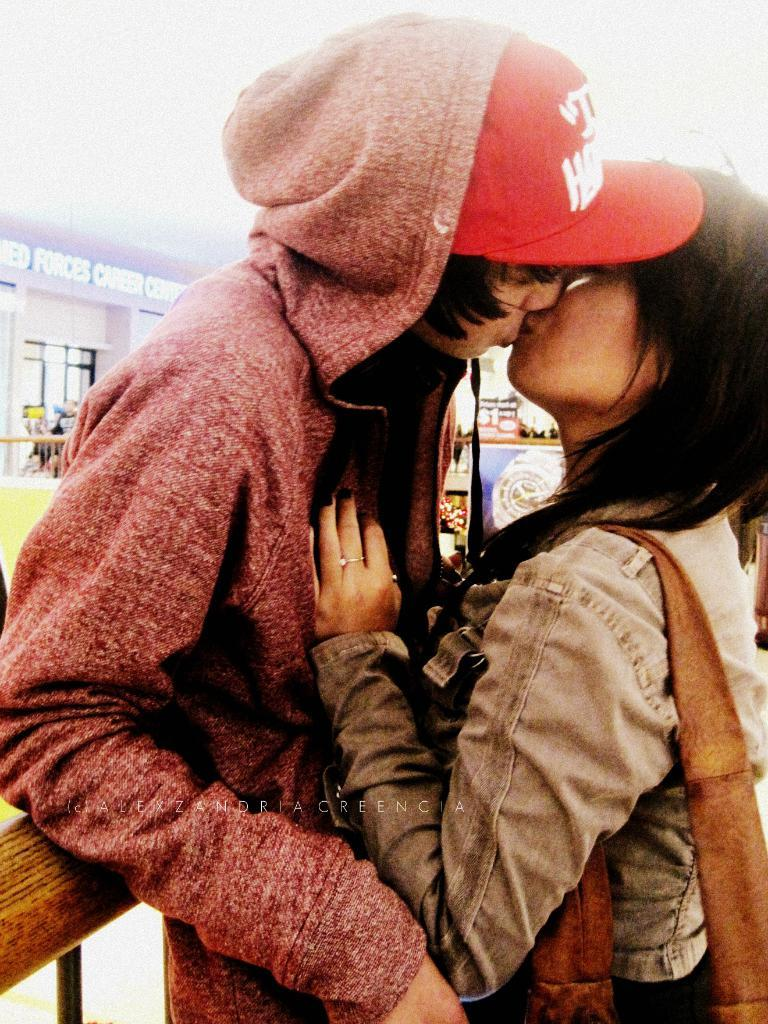How many people are in the image? There are two persons in the image. What are the two persons doing? The two persons are kissing. What can be seen in the background of the image? There is a wall and banners in the background of the image. Can you see any waves or the ocean in the image? There is no reference to waves or the ocean in the image; it features two people kissing with a wall and banners in the background. 